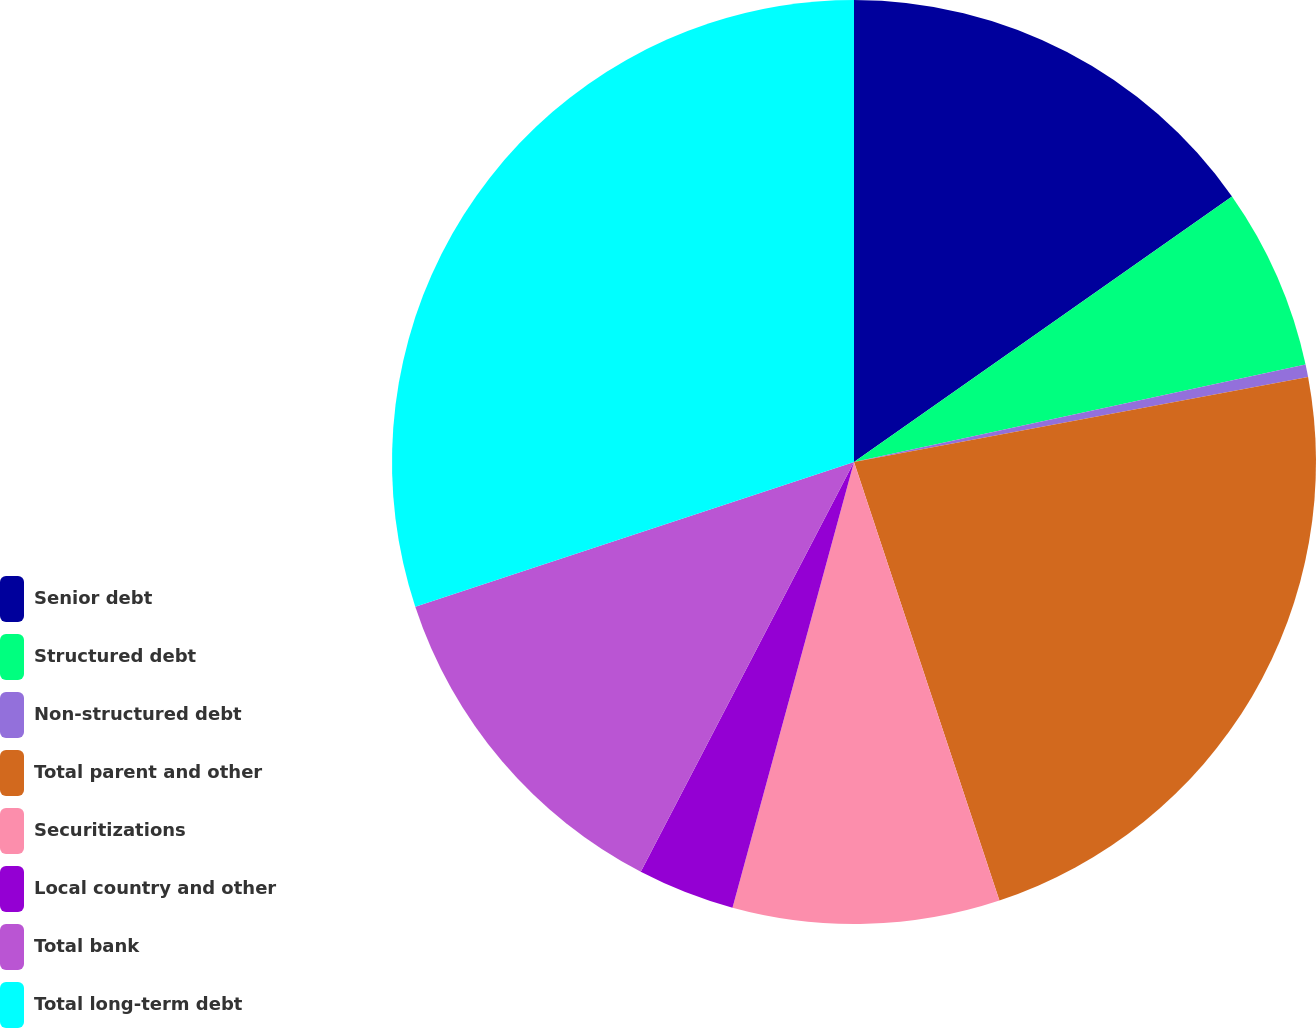<chart> <loc_0><loc_0><loc_500><loc_500><pie_chart><fcel>Senior debt<fcel>Structured debt<fcel>Non-structured debt<fcel>Total parent and other<fcel>Securitizations<fcel>Local country and other<fcel>Total bank<fcel>Total long-term debt<nl><fcel>15.25%<fcel>6.36%<fcel>0.44%<fcel>22.85%<fcel>9.33%<fcel>3.4%<fcel>12.29%<fcel>30.07%<nl></chart> 